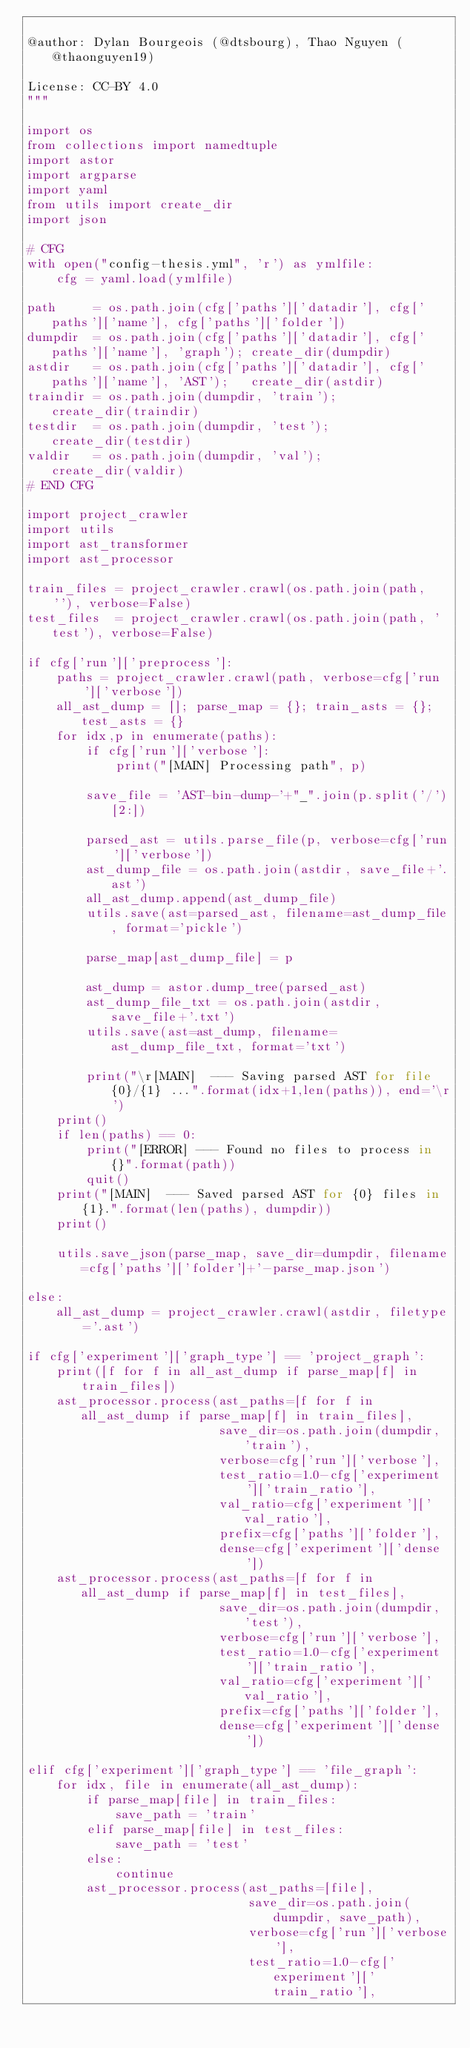<code> <loc_0><loc_0><loc_500><loc_500><_Python_>
@author: Dylan Bourgeois (@dtsbourg), Thao Nguyen (@thaonguyen19)

License: CC-BY 4.0
"""

import os
from collections import namedtuple
import astor
import argparse
import yaml
from utils import create_dir
import json

# CFG
with open("config-thesis.yml", 'r') as ymlfile:
    cfg = yaml.load(ymlfile)

path     = os.path.join(cfg['paths']['datadir'], cfg['paths']['name'], cfg['paths']['folder'])
dumpdir  = os.path.join(cfg['paths']['datadir'], cfg['paths']['name'], 'graph'); create_dir(dumpdir)
astdir   = os.path.join(cfg['paths']['datadir'], cfg['paths']['name'], 'AST');   create_dir(astdir)
traindir = os.path.join(dumpdir, 'train');              create_dir(traindir)
testdir  = os.path.join(dumpdir, 'test');               create_dir(testdir)
valdir   = os.path.join(dumpdir, 'val');                create_dir(valdir)
# END CFG

import project_crawler
import utils
import ast_transformer
import ast_processor

train_files = project_crawler.crawl(os.path.join(path, ''), verbose=False)
test_files  = project_crawler.crawl(os.path.join(path, 'test'), verbose=False)

if cfg['run']['preprocess']:
    paths = project_crawler.crawl(path, verbose=cfg['run']['verbose'])
    all_ast_dump = []; parse_map = {}; train_asts = {}; test_asts = {}
    for idx,p in enumerate(paths):
        if cfg['run']['verbose']:
            print("[MAIN] Processing path", p)

        save_file = 'AST-bin-dump-'+"_".join(p.split('/')[2:])

        parsed_ast = utils.parse_file(p, verbose=cfg['run']['verbose'])
        ast_dump_file = os.path.join(astdir, save_file+'.ast')
        all_ast_dump.append(ast_dump_file)
        utils.save(ast=parsed_ast, filename=ast_dump_file, format='pickle')

        parse_map[ast_dump_file] = p

        ast_dump = astor.dump_tree(parsed_ast)
        ast_dump_file_txt = os.path.join(astdir, save_file+'.txt')
        utils.save(ast=ast_dump, filename=ast_dump_file_txt, format='txt')

        print("\r[MAIN]  --- Saving parsed AST for file {0}/{1} ...".format(idx+1,len(paths)), end='\r')
    print()
    if len(paths) == 0:
        print("[ERROR] --- Found no files to process in {}".format(path))
        quit()
    print("[MAIN]  --- Saved parsed AST for {0} files in {1}.".format(len(paths), dumpdir))
    print()

    utils.save_json(parse_map, save_dir=dumpdir, filename=cfg['paths']['folder']+'-parse_map.json')

else:
    all_ast_dump = project_crawler.crawl(astdir, filetype='.ast')

if cfg['experiment']['graph_type'] == 'project_graph':
    print([f for f in all_ast_dump if parse_map[f] in train_files])
    ast_processor.process(ast_paths=[f for f in all_ast_dump if parse_map[f] in train_files],
                          save_dir=os.path.join(dumpdir, 'train'),
                          verbose=cfg['run']['verbose'],
                          test_ratio=1.0-cfg['experiment']['train_ratio'],
                          val_ratio=cfg['experiment']['val_ratio'],
                          prefix=cfg['paths']['folder'],
                          dense=cfg['experiment']['dense'])
    ast_processor.process(ast_paths=[f for f in all_ast_dump if parse_map[f] in test_files],
                          save_dir=os.path.join(dumpdir, 'test'),
                          verbose=cfg['run']['verbose'],
                          test_ratio=1.0-cfg['experiment']['train_ratio'],
                          val_ratio=cfg['experiment']['val_ratio'],
                          prefix=cfg['paths']['folder'],
                          dense=cfg['experiment']['dense'])

elif cfg['experiment']['graph_type'] == 'file_graph':
    for idx, file in enumerate(all_ast_dump):
        if parse_map[file] in train_files:
            save_path = 'train'
        elif parse_map[file] in test_files:
            save_path = 'test'
        else:
            continue
        ast_processor.process(ast_paths=[file],
                              save_dir=os.path.join(dumpdir, save_path),
                              verbose=cfg['run']['verbose'],
                              test_ratio=1.0-cfg['experiment']['train_ratio'],</code> 